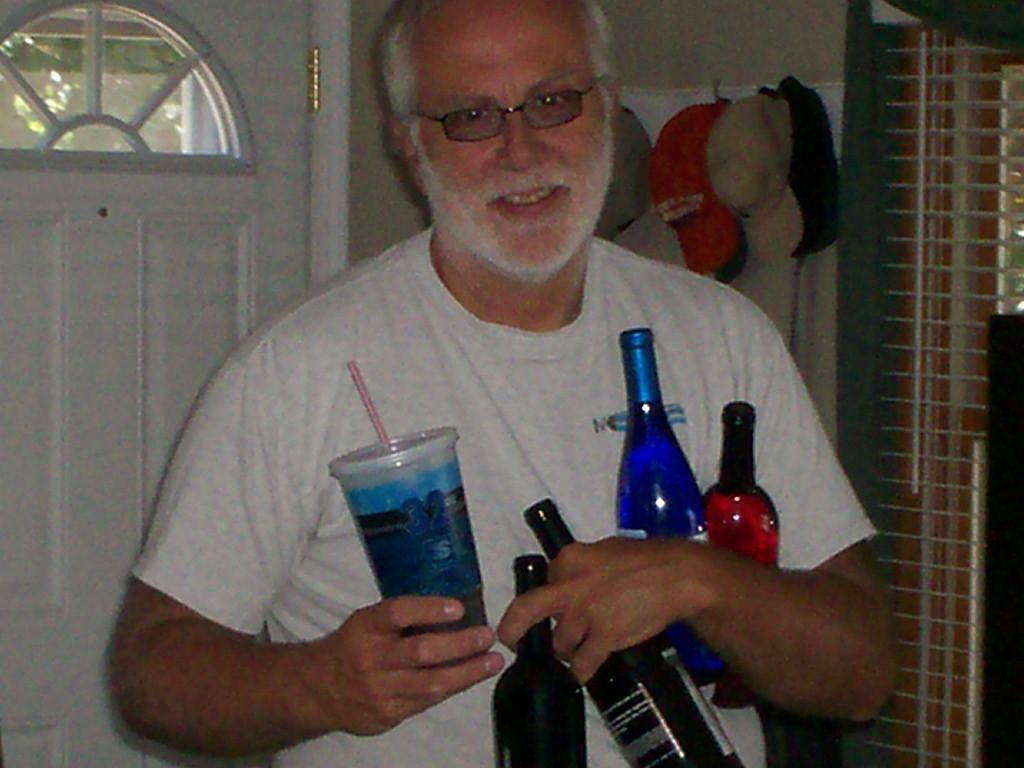What can be seen in the background of the image? There is a door in the background of the image. What type of accessory is visible in the image? There are caps visible in the image. Who is present in the image? There is a man in the image. What is the man wearing on his face? The man is wearing spectacles. What is the man wearing on his upper body? The man is wearing a white shirt. What is the man holding in his hands? The man is holding a tumbler glass and bottles in his hands. How many worms can be seen crawling on the man's shirt in the image? There are no worms present in the image; the man is wearing a white shirt. What type of trees are visible in the image? There are no trees visible in the image. 